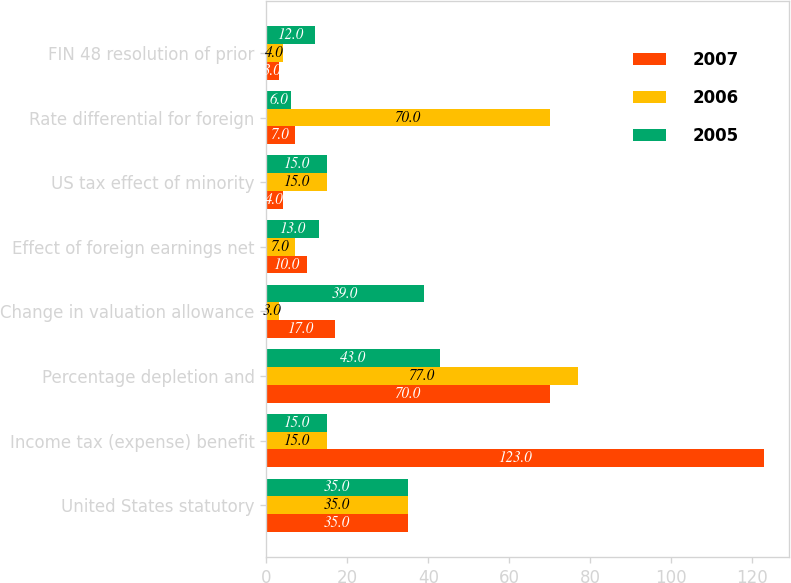Convert chart to OTSL. <chart><loc_0><loc_0><loc_500><loc_500><stacked_bar_chart><ecel><fcel>United States statutory<fcel>Income tax (expense) benefit<fcel>Percentage depletion and<fcel>Change in valuation allowance<fcel>Effect of foreign earnings net<fcel>US tax effect of minority<fcel>Rate differential for foreign<fcel>FIN 48 resolution of prior<nl><fcel>2007<fcel>35<fcel>123<fcel>70<fcel>17<fcel>10<fcel>4<fcel>7<fcel>3<nl><fcel>2006<fcel>35<fcel>15<fcel>77<fcel>3<fcel>7<fcel>15<fcel>70<fcel>4<nl><fcel>2005<fcel>35<fcel>15<fcel>43<fcel>39<fcel>13<fcel>15<fcel>6<fcel>12<nl></chart> 